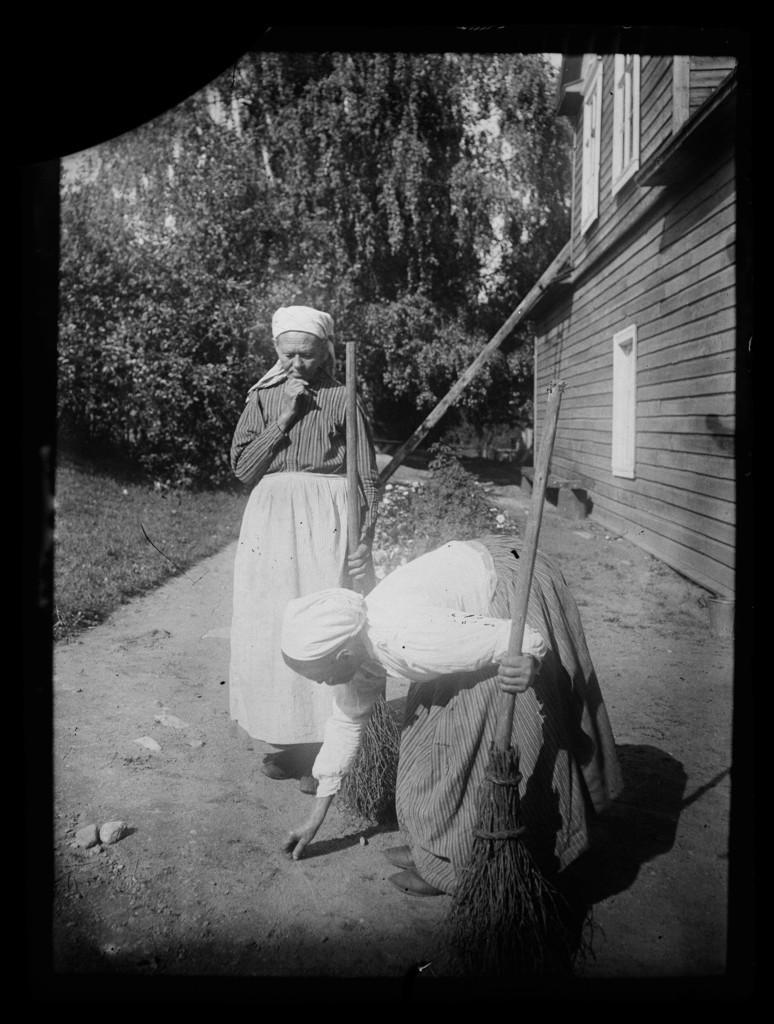How would you summarize this image in a sentence or two? It is a black and white image, there are two women and the second woman is picking something from the ground and behind them there are few trees and beside the trees there is a wooden house. 